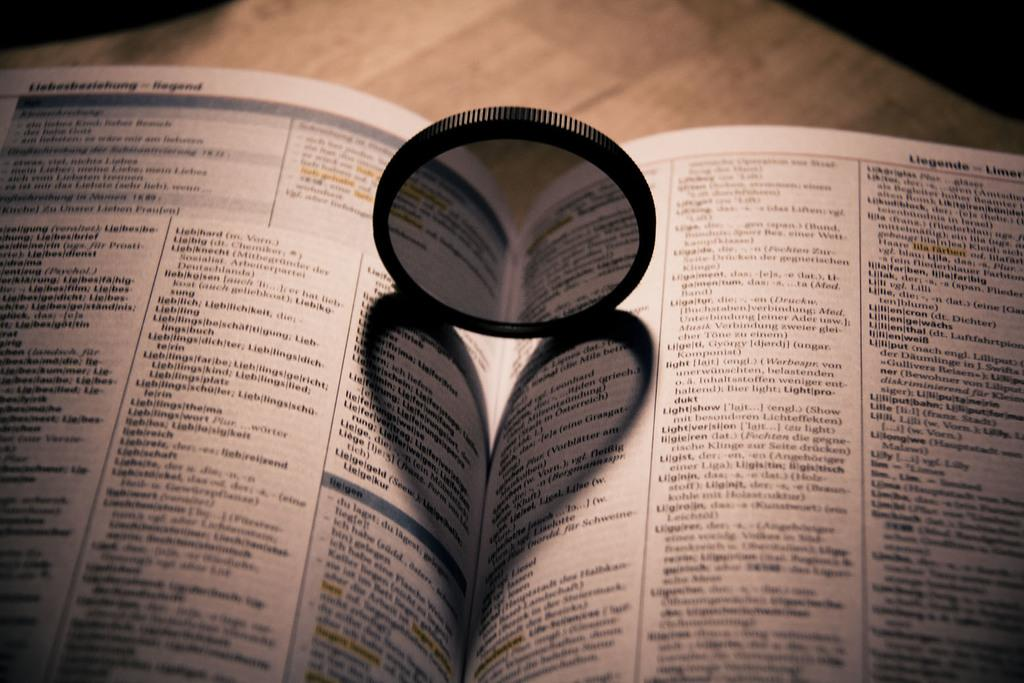Provide a one-sentence caption for the provided image. A phone book sits open on a table and lists many last names, including Liegende. 